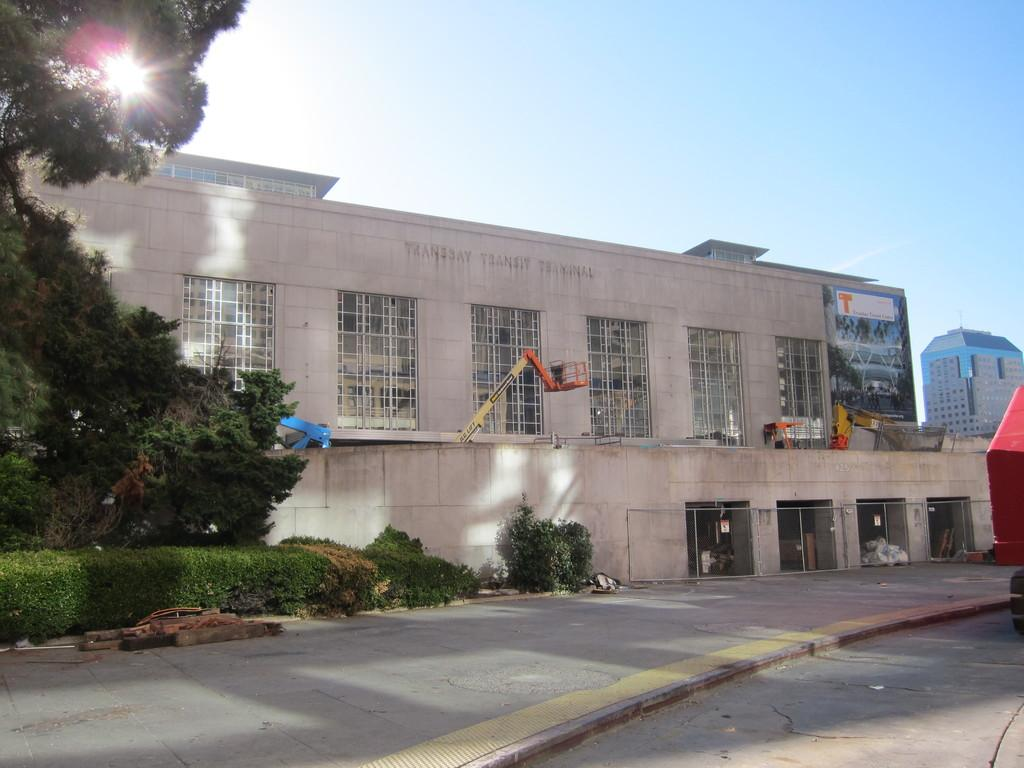What type of structures can be seen in the image? There are buildings in the image. What equipment is present in the image? There are cranes in the image. What type of vegetation is visible in the image? There are trees and plants in the image. How would you describe the sky in the image? The sky is blue and cloudy in the image. What type of bird can be seen flying over the mine in the image? There is no bird or mine present in the image. 